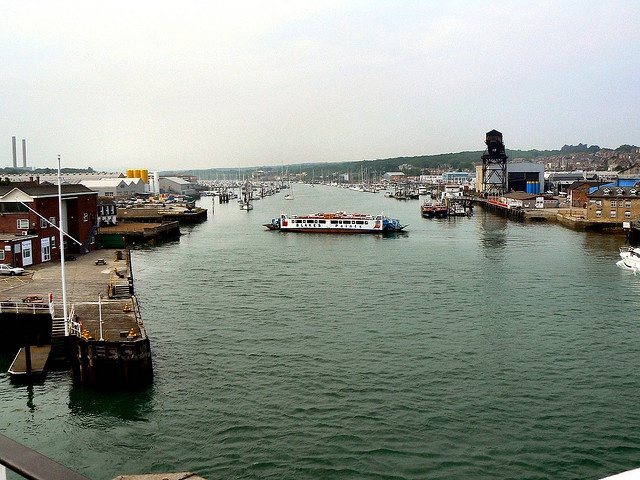Describe the objects in this image and their specific colors. I can see boat in white, black, maroon, and darkgray tones, boat in white, ivory, darkgray, gray, and black tones, car in white, black, darkgray, and gray tones, boat in white, black, darkgray, gray, and lightgray tones, and boat in white, black, brown, gray, and darkgray tones in this image. 